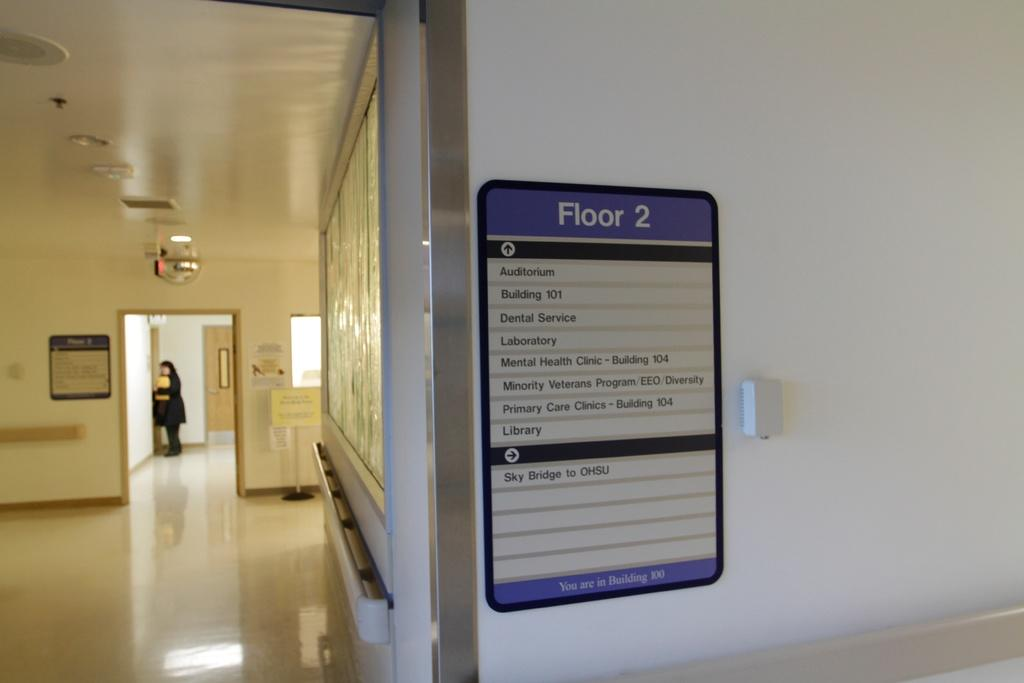What is attached to the walls in the image? There are boards attached to the walls in the image. What can be seen in the center of the image? There is a pole in the image. What is the person in the image standing on? The person is standing on the floor in the image. What type of decorations are visible in the image? There are posters visible in the image. What is used for illumination in the image? There are lights in the image. What type of oatmeal is being prepared in the image? There is no oatmeal present in the image. What is the person's journey in the image? The image does not depict a journey; it shows a person standing on the floor with boards, a pole, posters, and lights in the background. 